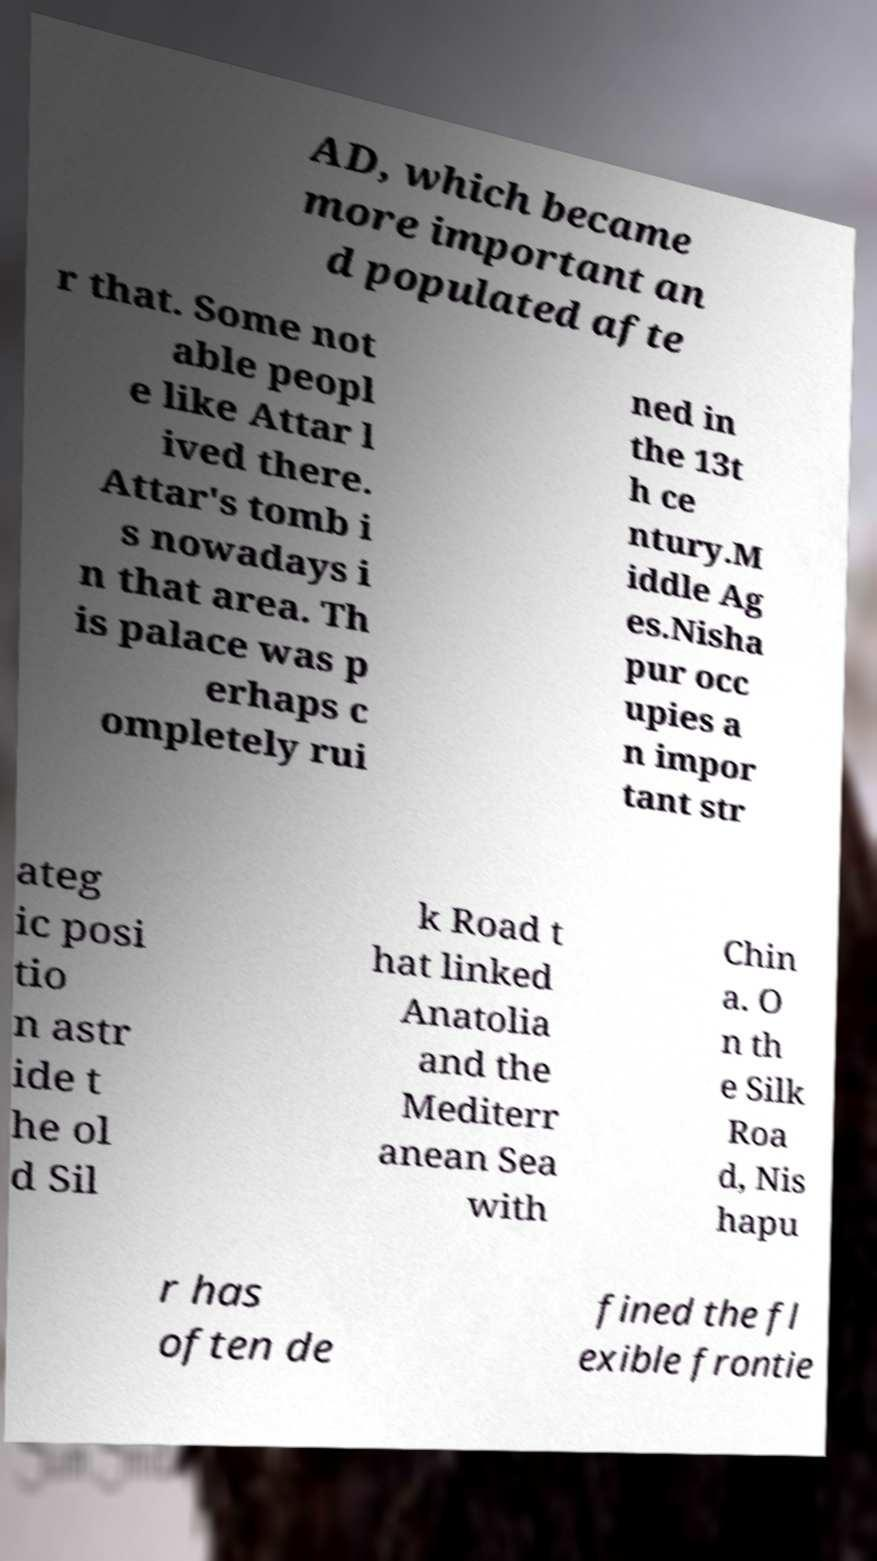Could you assist in decoding the text presented in this image and type it out clearly? AD, which became more important an d populated afte r that. Some not able peopl e like Attar l ived there. Attar's tomb i s nowadays i n that area. Th is palace was p erhaps c ompletely rui ned in the 13t h ce ntury.M iddle Ag es.Nisha pur occ upies a n impor tant str ateg ic posi tio n astr ide t he ol d Sil k Road t hat linked Anatolia and the Mediterr anean Sea with Chin a. O n th e Silk Roa d, Nis hapu r has often de fined the fl exible frontie 